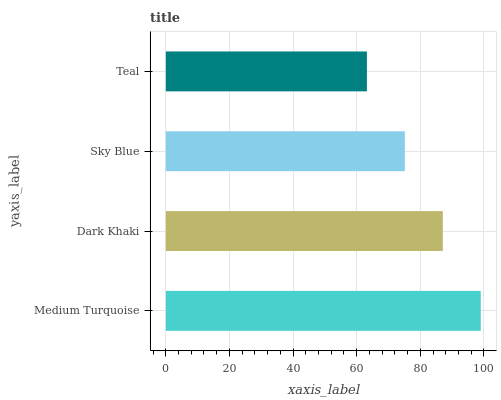Is Teal the minimum?
Answer yes or no. Yes. Is Medium Turquoise the maximum?
Answer yes or no. Yes. Is Dark Khaki the minimum?
Answer yes or no. No. Is Dark Khaki the maximum?
Answer yes or no. No. Is Medium Turquoise greater than Dark Khaki?
Answer yes or no. Yes. Is Dark Khaki less than Medium Turquoise?
Answer yes or no. Yes. Is Dark Khaki greater than Medium Turquoise?
Answer yes or no. No. Is Medium Turquoise less than Dark Khaki?
Answer yes or no. No. Is Dark Khaki the high median?
Answer yes or no. Yes. Is Sky Blue the low median?
Answer yes or no. Yes. Is Sky Blue the high median?
Answer yes or no. No. Is Medium Turquoise the low median?
Answer yes or no. No. 